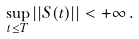Convert formula to latex. <formula><loc_0><loc_0><loc_500><loc_500>\sup _ { t \leq T } | | S ( t ) | | < + \infty \, .</formula> 